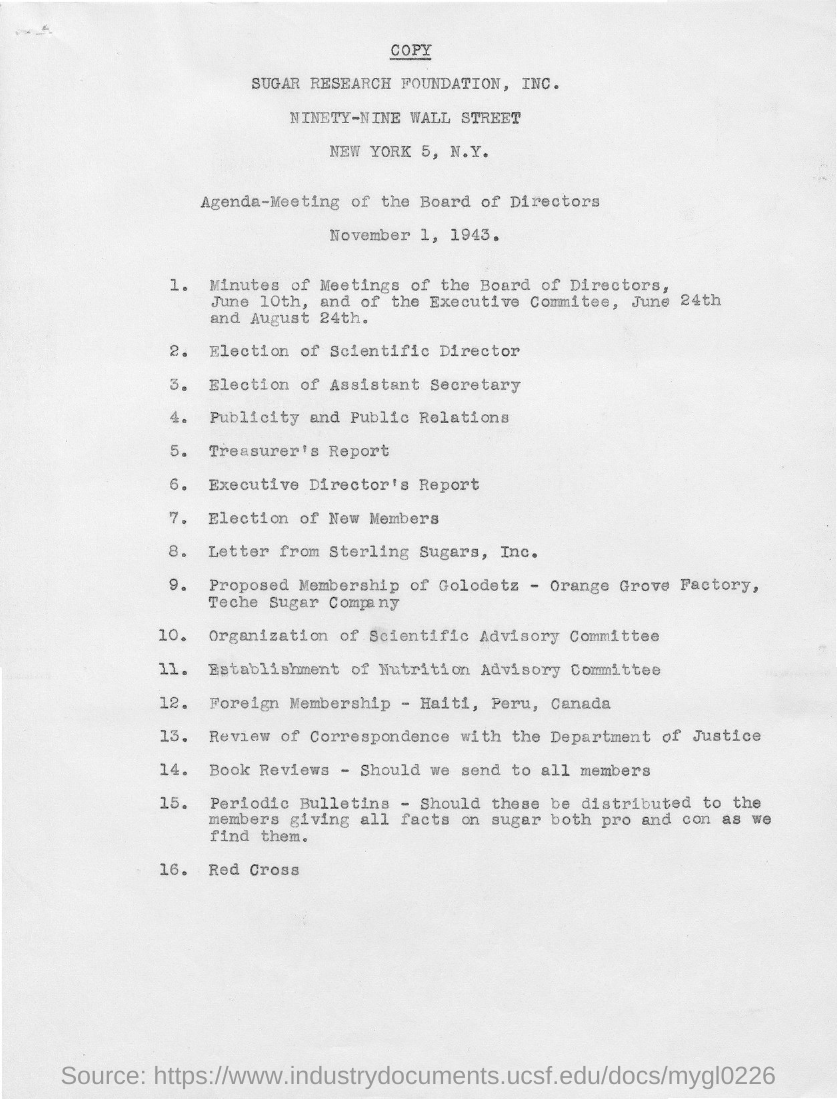Who might be interested in the outcome of this 1943 board meeting? Stakeholders in the Sugar Research Foundation, including employees, investors, and members of the scientific community, would be interested in the outcomes. Additionally, entities like Sterling Sugars, Inc. and other members mentioned in the international community from Haiti, Peru, and Canada may also hold interest in the decisions made during this meeting. Why would international members be interested? International members may be interested due to the foundation’s influential research and policy decisions affecting the global sugar market and scientific collaborations. The establishment of advisory committees and the dissemination of periodic bulletins also suggest a broad dissemination of information that could impact these members. 